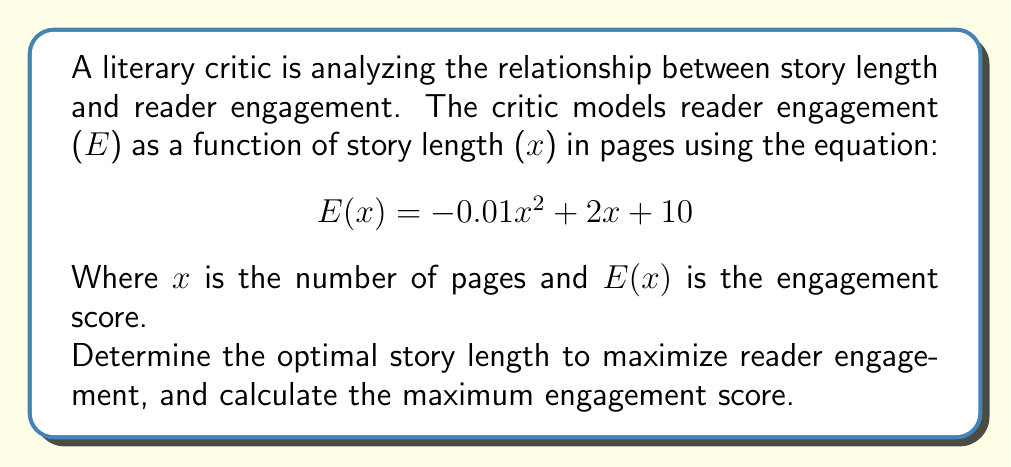Teach me how to tackle this problem. To solve this optimization problem, we need to follow these steps:

1. Identify the function to be maximized:
   $$ E(x) = -0.01x^2 + 2x + 10 $$

2. Find the derivative of the function:
   $$ E'(x) = -0.02x + 2 $$

3. Set the derivative equal to zero and solve for x:
   $$ -0.02x + 2 = 0 $$
   $$ -0.02x = -2 $$
   $$ x = 100 $$

4. Verify that this critical point is a maximum by checking the second derivative:
   $$ E''(x) = -0.02 $$
   Since $E''(x)$ is negative, the critical point is a maximum.

5. Calculate the maximum engagement score by plugging x = 100 into the original function:
   $$ E(100) = -0.01(100)^2 + 2(100) + 10 $$
   $$ = -100 + 200 + 10 $$
   $$ = 110 $$

This approach mirrors the literary critic's analysis of storytelling techniques, where finding the optimal balance between brevity and depth is crucial for maintaining reader engagement.
Answer: The optimal story length is 100 pages, and the maximum engagement score is 110. 